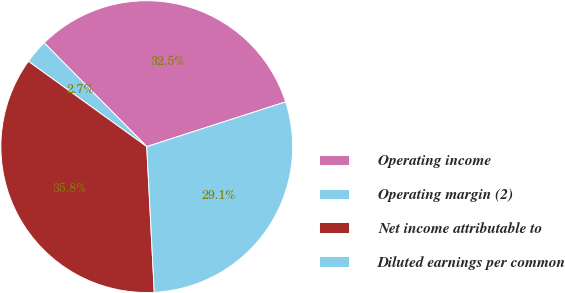<chart> <loc_0><loc_0><loc_500><loc_500><pie_chart><fcel>Operating income<fcel>Operating margin (2)<fcel>Net income attributable to<fcel>Diluted earnings per common<nl><fcel>32.45%<fcel>2.65%<fcel>35.76%<fcel>29.14%<nl></chart> 